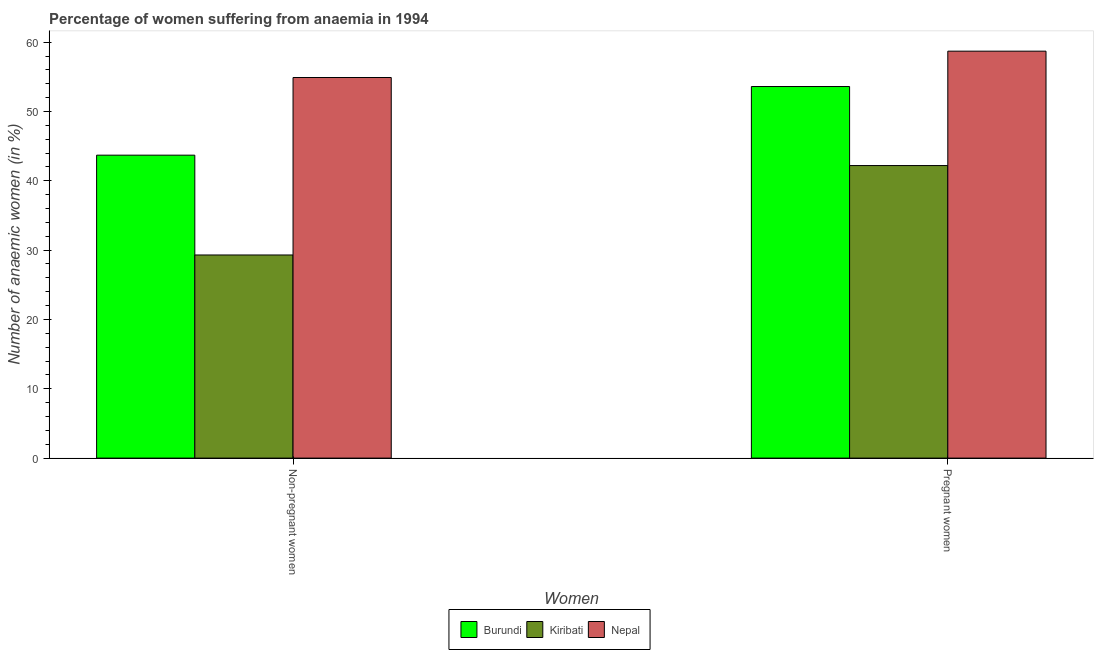Are the number of bars per tick equal to the number of legend labels?
Offer a terse response. Yes. How many bars are there on the 1st tick from the left?
Ensure brevity in your answer.  3. What is the label of the 1st group of bars from the left?
Offer a terse response. Non-pregnant women. What is the percentage of non-pregnant anaemic women in Kiribati?
Ensure brevity in your answer.  29.3. Across all countries, what is the maximum percentage of pregnant anaemic women?
Ensure brevity in your answer.  58.7. Across all countries, what is the minimum percentage of non-pregnant anaemic women?
Your response must be concise. 29.3. In which country was the percentage of pregnant anaemic women maximum?
Ensure brevity in your answer.  Nepal. In which country was the percentage of pregnant anaemic women minimum?
Ensure brevity in your answer.  Kiribati. What is the total percentage of non-pregnant anaemic women in the graph?
Offer a terse response. 127.9. What is the difference between the percentage of pregnant anaemic women in Kiribati and that in Nepal?
Give a very brief answer. -16.5. What is the difference between the percentage of non-pregnant anaemic women in Nepal and the percentage of pregnant anaemic women in Burundi?
Provide a succinct answer. 1.3. What is the average percentage of pregnant anaemic women per country?
Provide a short and direct response. 51.5. What is the difference between the percentage of pregnant anaemic women and percentage of non-pregnant anaemic women in Nepal?
Keep it short and to the point. 3.8. In how many countries, is the percentage of pregnant anaemic women greater than 36 %?
Provide a succinct answer. 3. What is the ratio of the percentage of pregnant anaemic women in Kiribati to that in Burundi?
Your answer should be very brief. 0.79. In how many countries, is the percentage of non-pregnant anaemic women greater than the average percentage of non-pregnant anaemic women taken over all countries?
Offer a terse response. 2. What does the 3rd bar from the left in Pregnant women represents?
Your response must be concise. Nepal. What does the 2nd bar from the right in Pregnant women represents?
Your response must be concise. Kiribati. How many bars are there?
Provide a short and direct response. 6. How many countries are there in the graph?
Give a very brief answer. 3. Are the values on the major ticks of Y-axis written in scientific E-notation?
Provide a succinct answer. No. Does the graph contain any zero values?
Ensure brevity in your answer.  No. Where does the legend appear in the graph?
Ensure brevity in your answer.  Bottom center. How many legend labels are there?
Give a very brief answer. 3. How are the legend labels stacked?
Your response must be concise. Horizontal. What is the title of the graph?
Keep it short and to the point. Percentage of women suffering from anaemia in 1994. Does "Greece" appear as one of the legend labels in the graph?
Provide a succinct answer. No. What is the label or title of the X-axis?
Provide a short and direct response. Women. What is the label or title of the Y-axis?
Give a very brief answer. Number of anaemic women (in %). What is the Number of anaemic women (in %) in Burundi in Non-pregnant women?
Make the answer very short. 43.7. What is the Number of anaemic women (in %) in Kiribati in Non-pregnant women?
Your answer should be very brief. 29.3. What is the Number of anaemic women (in %) in Nepal in Non-pregnant women?
Give a very brief answer. 54.9. What is the Number of anaemic women (in %) of Burundi in Pregnant women?
Provide a short and direct response. 53.6. What is the Number of anaemic women (in %) of Kiribati in Pregnant women?
Ensure brevity in your answer.  42.2. What is the Number of anaemic women (in %) of Nepal in Pregnant women?
Provide a succinct answer. 58.7. Across all Women, what is the maximum Number of anaemic women (in %) in Burundi?
Ensure brevity in your answer.  53.6. Across all Women, what is the maximum Number of anaemic women (in %) of Kiribati?
Make the answer very short. 42.2. Across all Women, what is the maximum Number of anaemic women (in %) in Nepal?
Give a very brief answer. 58.7. Across all Women, what is the minimum Number of anaemic women (in %) of Burundi?
Give a very brief answer. 43.7. Across all Women, what is the minimum Number of anaemic women (in %) in Kiribati?
Provide a short and direct response. 29.3. Across all Women, what is the minimum Number of anaemic women (in %) in Nepal?
Give a very brief answer. 54.9. What is the total Number of anaemic women (in %) in Burundi in the graph?
Your answer should be very brief. 97.3. What is the total Number of anaemic women (in %) in Kiribati in the graph?
Ensure brevity in your answer.  71.5. What is the total Number of anaemic women (in %) of Nepal in the graph?
Your answer should be very brief. 113.6. What is the difference between the Number of anaemic women (in %) in Kiribati in Non-pregnant women and that in Pregnant women?
Your response must be concise. -12.9. What is the difference between the Number of anaemic women (in %) of Kiribati in Non-pregnant women and the Number of anaemic women (in %) of Nepal in Pregnant women?
Provide a succinct answer. -29.4. What is the average Number of anaemic women (in %) in Burundi per Women?
Your answer should be compact. 48.65. What is the average Number of anaemic women (in %) of Kiribati per Women?
Offer a terse response. 35.75. What is the average Number of anaemic women (in %) of Nepal per Women?
Your answer should be compact. 56.8. What is the difference between the Number of anaemic women (in %) in Burundi and Number of anaemic women (in %) in Nepal in Non-pregnant women?
Offer a terse response. -11.2. What is the difference between the Number of anaemic women (in %) of Kiribati and Number of anaemic women (in %) of Nepal in Non-pregnant women?
Keep it short and to the point. -25.6. What is the difference between the Number of anaemic women (in %) in Burundi and Number of anaemic women (in %) in Nepal in Pregnant women?
Offer a very short reply. -5.1. What is the difference between the Number of anaemic women (in %) in Kiribati and Number of anaemic women (in %) in Nepal in Pregnant women?
Ensure brevity in your answer.  -16.5. What is the ratio of the Number of anaemic women (in %) in Burundi in Non-pregnant women to that in Pregnant women?
Provide a short and direct response. 0.82. What is the ratio of the Number of anaemic women (in %) in Kiribati in Non-pregnant women to that in Pregnant women?
Offer a terse response. 0.69. What is the ratio of the Number of anaemic women (in %) of Nepal in Non-pregnant women to that in Pregnant women?
Keep it short and to the point. 0.94. What is the difference between the highest and the second highest Number of anaemic women (in %) of Burundi?
Your response must be concise. 9.9. What is the difference between the highest and the second highest Number of anaemic women (in %) of Nepal?
Offer a terse response. 3.8. What is the difference between the highest and the lowest Number of anaemic women (in %) in Kiribati?
Offer a terse response. 12.9. What is the difference between the highest and the lowest Number of anaemic women (in %) of Nepal?
Give a very brief answer. 3.8. 